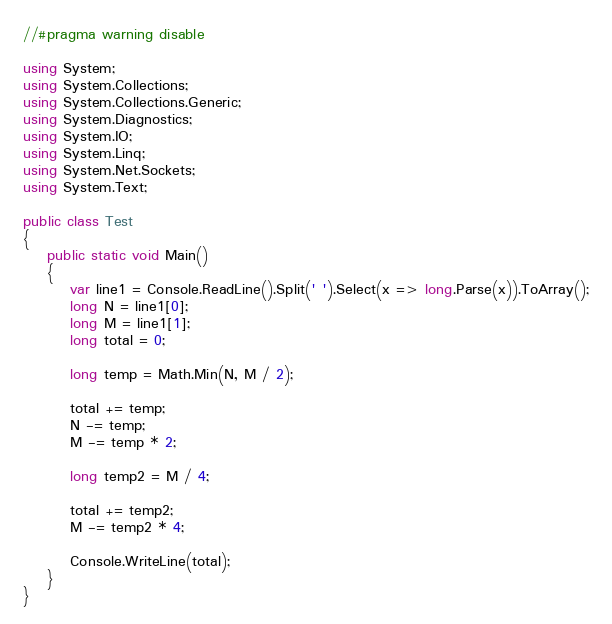<code> <loc_0><loc_0><loc_500><loc_500><_C#_>//#pragma warning disable

using System;
using System.Collections;
using System.Collections.Generic;
using System.Diagnostics;
using System.IO;
using System.Linq;
using System.Net.Sockets;
using System.Text;

public class Test
{
    public static void Main()
    {
        var line1 = Console.ReadLine().Split(' ').Select(x => long.Parse(x)).ToArray();
        long N = line1[0];
        long M = line1[1];
        long total = 0;

        long temp = Math.Min(N, M / 2);

        total += temp;
        N -= temp;
        M -= temp * 2;

        long temp2 = M / 4;

        total += temp2;
        M -= temp2 * 4;

        Console.WriteLine(total);
    }
}</code> 